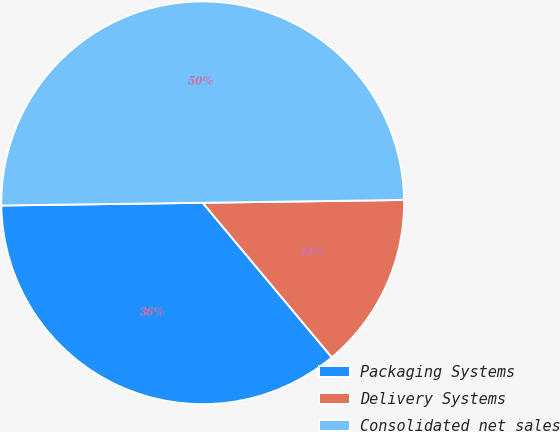<chart> <loc_0><loc_0><loc_500><loc_500><pie_chart><fcel>Packaging Systems<fcel>Delivery Systems<fcel>Consolidated net sales<nl><fcel>35.86%<fcel>14.15%<fcel>49.99%<nl></chart> 